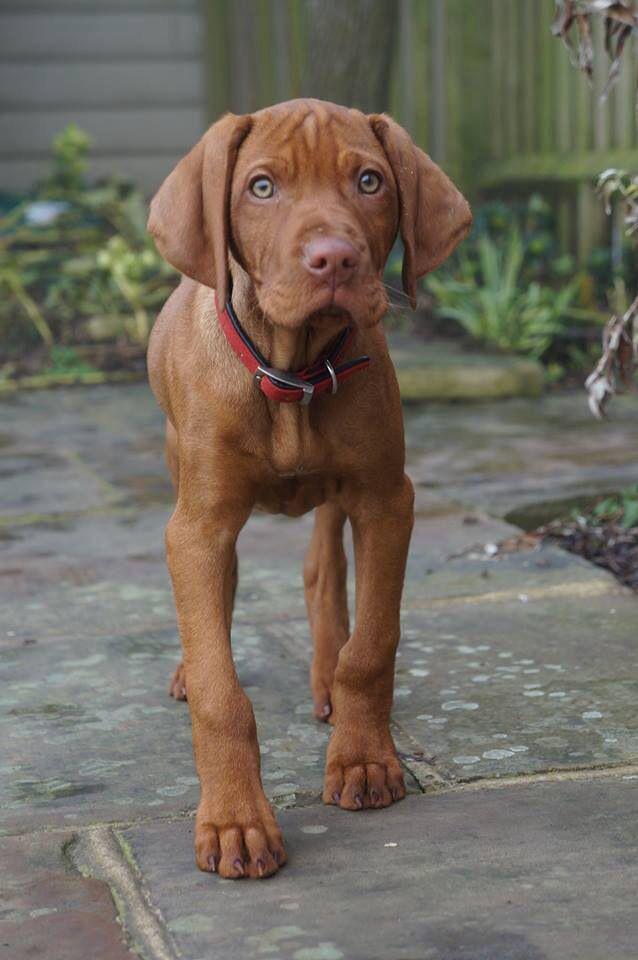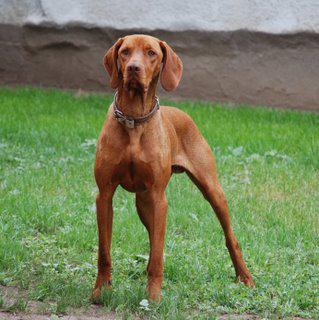The first image is the image on the left, the second image is the image on the right. For the images displayed, is the sentence "There are two dogs in one image and one dog in the other image." factually correct? Answer yes or no. No. 